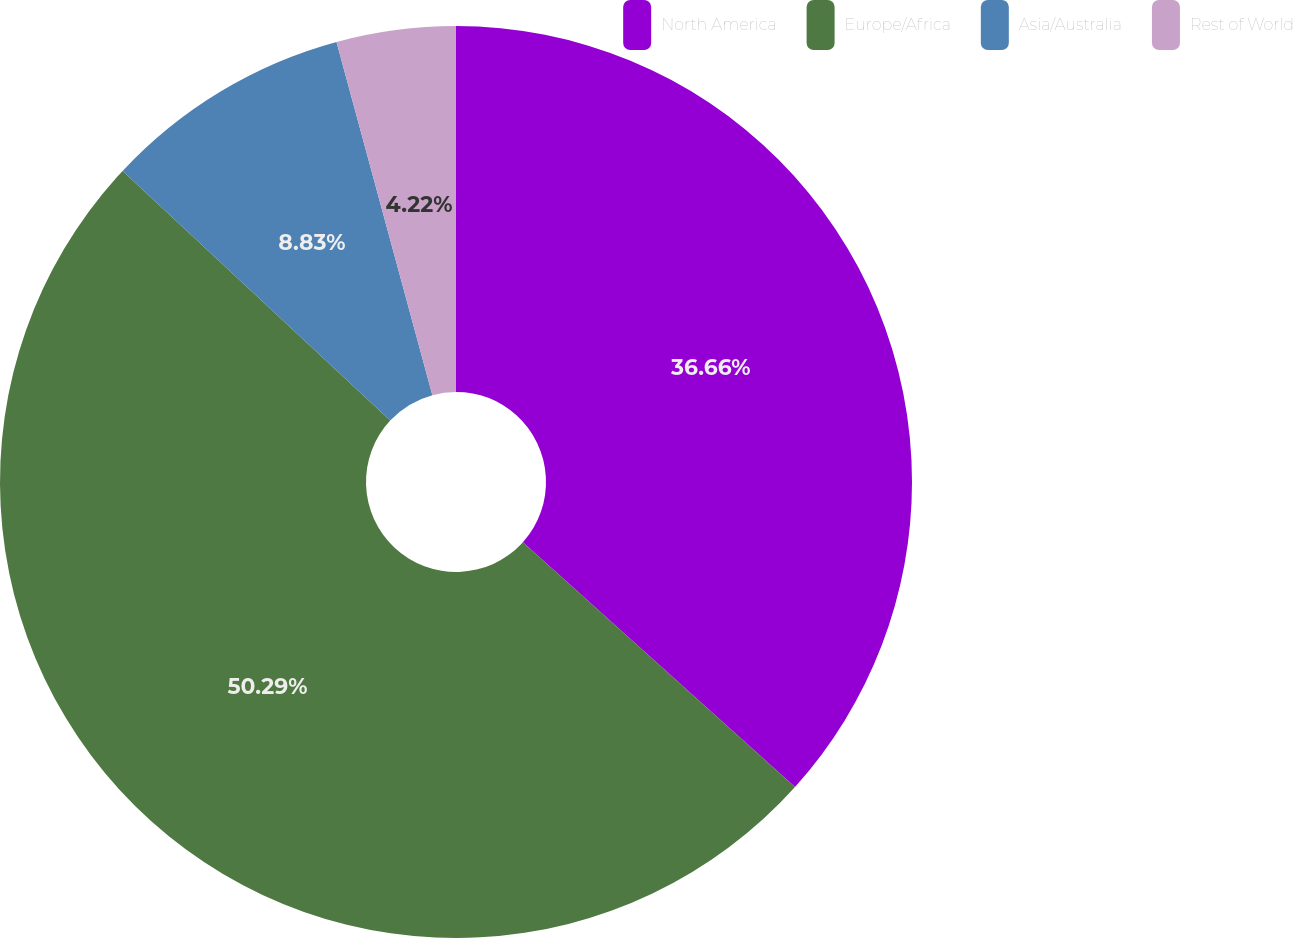<chart> <loc_0><loc_0><loc_500><loc_500><pie_chart><fcel>North America<fcel>Europe/Africa<fcel>Asia/Australia<fcel>Rest of World<nl><fcel>36.66%<fcel>50.29%<fcel>8.83%<fcel>4.22%<nl></chart> 